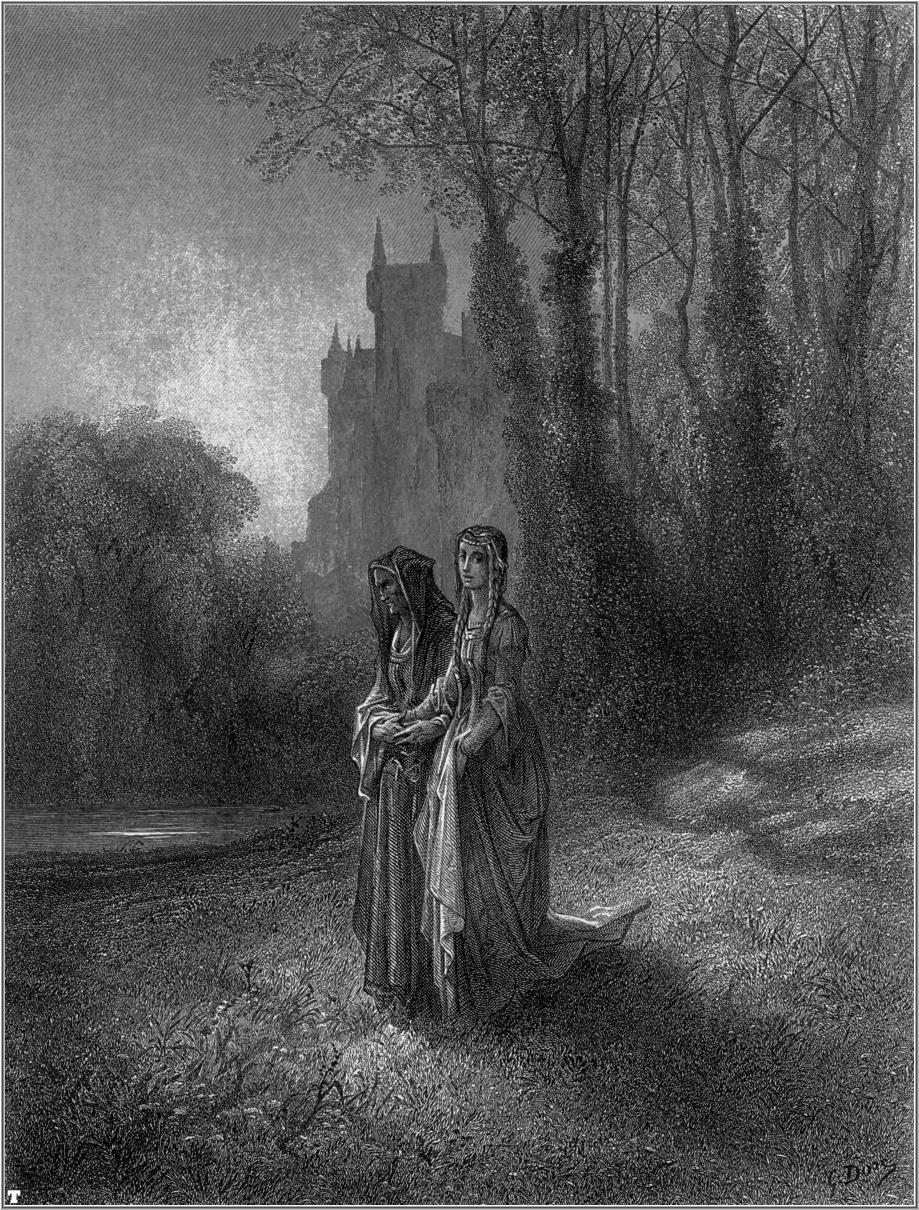Describe the atmosphere of the forest in the illustration. The atmosphere of the forest in the illustration is imbued with a sense of calm and tranquility. The intricate shading and attention to detail in the foliage create a dense, almost tangible texture, making the forest feel both expansive and intimate. The misty backdrop and soft lighting cast a serene and somewhat ethereal glow over the scene, suggesting an early morning or late afternoon setting. The towering trees, with their leafy canopies, add to the feeling of seclusion, as if the forest is a sanctuary away from the bustle of everyday life. The overall mood is one of peaceful reflection, heightened by the distant, enigmatic presence of the castle, which adds a touch of mystery and historic charm to the scene. 